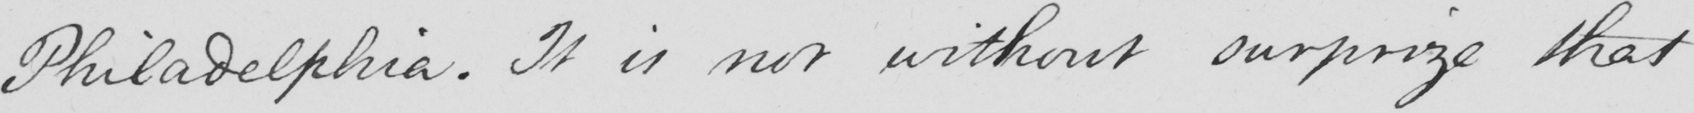What does this handwritten line say? Philadelphia . It is not without surprize that 